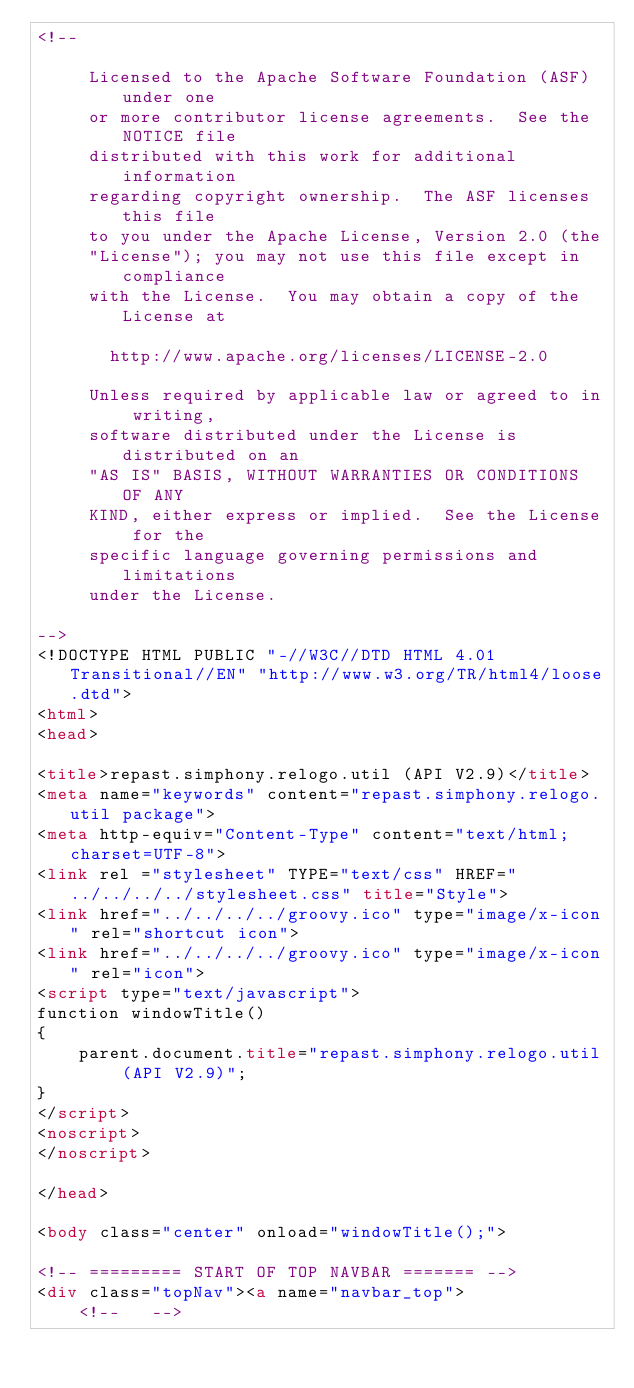Convert code to text. <code><loc_0><loc_0><loc_500><loc_500><_HTML_><!--

     Licensed to the Apache Software Foundation (ASF) under one
     or more contributor license agreements.  See the NOTICE file
     distributed with this work for additional information
     regarding copyright ownership.  The ASF licenses this file
     to you under the Apache License, Version 2.0 (the
     "License"); you may not use this file except in compliance
     with the License.  You may obtain a copy of the License at

       http://www.apache.org/licenses/LICENSE-2.0

     Unless required by applicable law or agreed to in writing,
     software distributed under the License is distributed on an
     "AS IS" BASIS, WITHOUT WARRANTIES OR CONDITIONS OF ANY
     KIND, either express or implied.  See the License for the
     specific language governing permissions and limitations
     under the License.

-->
<!DOCTYPE HTML PUBLIC "-//W3C//DTD HTML 4.01 Transitional//EN" "http://www.w3.org/TR/html4/loose.dtd">
<html>
<head>

<title>repast.simphony.relogo.util (API V2.9)</title>
<meta name="keywords" content="repast.simphony.relogo.util package">
<meta http-equiv="Content-Type" content="text/html; charset=UTF-8">
<link rel ="stylesheet" TYPE="text/css" HREF="../../../../stylesheet.css" title="Style">
<link href="../../../../groovy.ico" type="image/x-icon" rel="shortcut icon">
<link href="../../../../groovy.ico" type="image/x-icon" rel="icon">
<script type="text/javascript">
function windowTitle()
{
    parent.document.title="repast.simphony.relogo.util (API V2.9)";
}
</script>
<noscript>
</noscript>

</head>

<body class="center" onload="windowTitle();">

<!-- ========= START OF TOP NAVBAR ======= -->
<div class="topNav"><a name="navbar_top">
    <!--   --></code> 